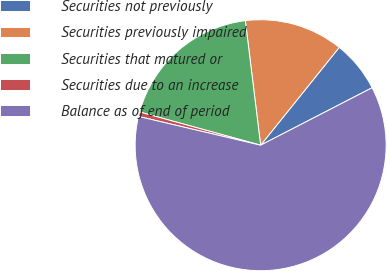Convert chart to OTSL. <chart><loc_0><loc_0><loc_500><loc_500><pie_chart><fcel>Securities not previously<fcel>Securities previously impaired<fcel>Securities that matured or<fcel>Securities due to an increase<fcel>Balance as of end of period<nl><fcel>6.65%<fcel>12.72%<fcel>18.79%<fcel>0.58%<fcel>61.26%<nl></chart> 